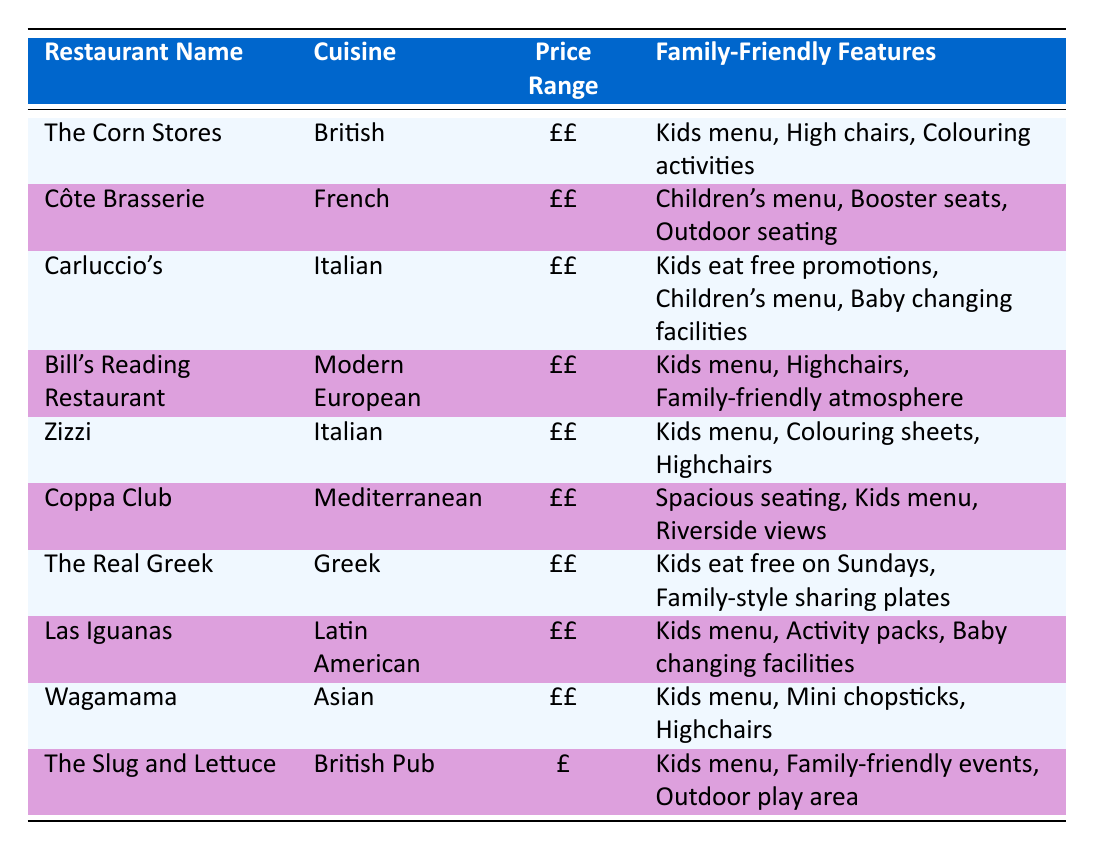What family-friendly features does Zizzi have? According to the table, Zizzi has "Kids menu, Colouring sheets, Highchairs" listed as its family-friendly features.
Answer: Kids menu, Colouring sheets, Highchairs Which restaurant offers a children's menu and booster seats? The restaurant Côte Brasserie is the one that provides a children's menu and booster seats, as specified in the relevant row of the table.
Answer: Côte Brasserie Is there a family-friendly restaurant in Reading that has outdoor seating? Yes, both Côte Brasserie and Coppa Club are listed in the table as having outdoor seating among their family-friendly features.
Answer: Yes Which cuisine type is associated with the restaurant that offers kids eat free promotions? Carluccio's, which serves Italian cuisine, is associated with kids eat free promotions as one of its family-friendly features.
Answer: Italian How many restaurants have "Kids menu" listed as a family-friendly feature? The table shows that there are six restaurants with "Kids menu" as a family-friendly feature: The Corn Stores, Bill's Reading Restaurant, Zizzi, Coppa Club, Las Iguanas, and Wagamama. This is a total of six restaurants.
Answer: 6 What is the price range of The Slug and Lettuce? The Slug and Lettuce is categorized in the table as having a price range of "£".
Answer: £ Which restaurant has the most variety in family-friendly features? The Real Greek has the most variety in family-friendly features, offering "Kids eat free on Sundays" and "Family-style sharing plates," indicating a focus on family dining experience.
Answer: The Real Greek Is there any restaurant in Reading with a family-friendly outdoor play area? Yes, The Slug and Lettuce has an outdoor play area listed as one of its family-friendly features.
Answer: Yes 